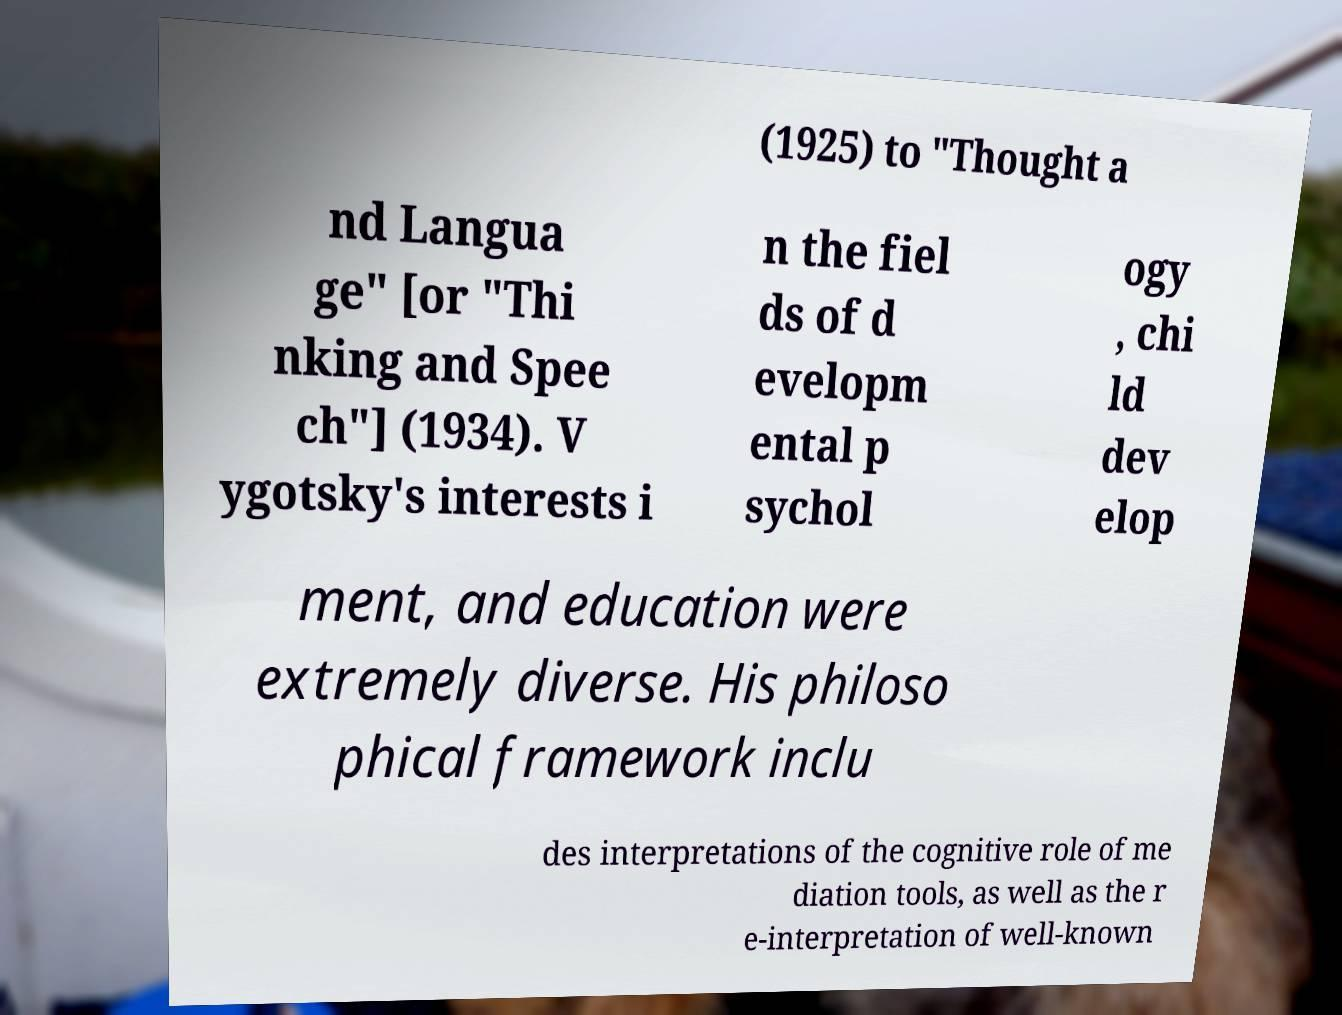Could you assist in decoding the text presented in this image and type it out clearly? (1925) to "Thought a nd Langua ge" [or "Thi nking and Spee ch"] (1934). V ygotsky's interests i n the fiel ds of d evelopm ental p sychol ogy , chi ld dev elop ment, and education were extremely diverse. His philoso phical framework inclu des interpretations of the cognitive role of me diation tools, as well as the r e-interpretation of well-known 